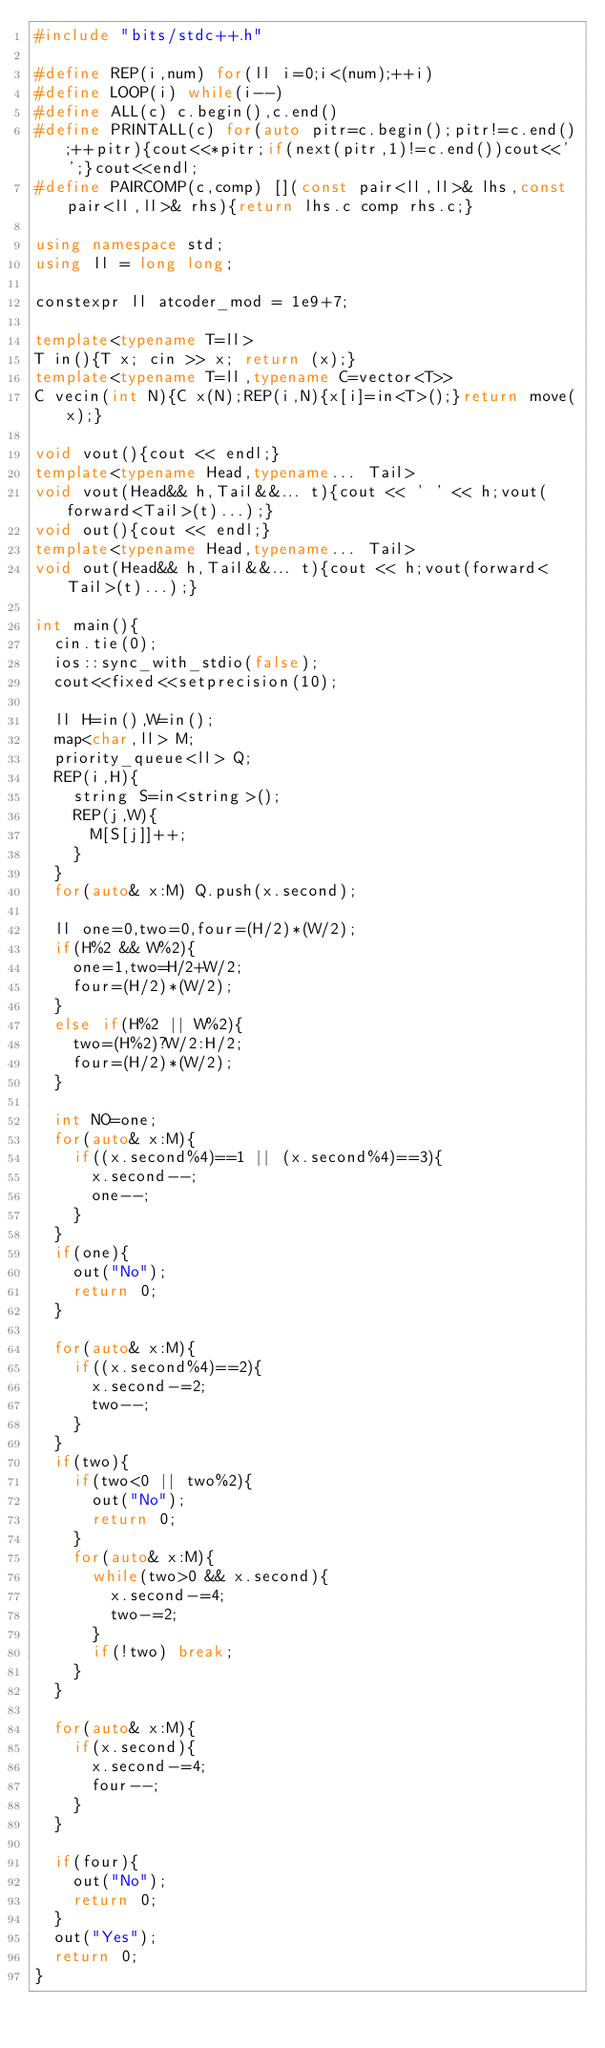Convert code to text. <code><loc_0><loc_0><loc_500><loc_500><_C++_>#include "bits/stdc++.h"

#define REP(i,num) for(ll i=0;i<(num);++i)
#define LOOP(i) while(i--)
#define ALL(c) c.begin(),c.end()
#define PRINTALL(c) for(auto pitr=c.begin();pitr!=c.end();++pitr){cout<<*pitr;if(next(pitr,1)!=c.end())cout<<' ';}cout<<endl;
#define PAIRCOMP(c,comp) [](const pair<ll,ll>& lhs,const pair<ll,ll>& rhs){return lhs.c comp rhs.c;}

using namespace std;
using ll = long long;

constexpr ll atcoder_mod = 1e9+7;

template<typename T=ll>
T in(){T x; cin >> x; return (x);}
template<typename T=ll,typename C=vector<T>>
C vecin(int N){C x(N);REP(i,N){x[i]=in<T>();}return move(x);}

void vout(){cout << endl;}
template<typename Head,typename... Tail>
void vout(Head&& h,Tail&&... t){cout << ' ' << h;vout(forward<Tail>(t)...);}
void out(){cout << endl;}
template<typename Head,typename... Tail>
void out(Head&& h,Tail&&... t){cout << h;vout(forward<Tail>(t)...);}

int main(){
	cin.tie(0);
	ios::sync_with_stdio(false);
	cout<<fixed<<setprecision(10);

	ll H=in(),W=in();
	map<char,ll> M;
	priority_queue<ll> Q;
	REP(i,H){
		string S=in<string>();
		REP(j,W){
			M[S[j]]++;
		}
	}
	for(auto& x:M) Q.push(x.second);

	ll one=0,two=0,four=(H/2)*(W/2);
	if(H%2 && W%2){
		one=1,two=H/2+W/2;
		four=(H/2)*(W/2);
	}
	else if(H%2 || W%2){
		two=(H%2)?W/2:H/2;
		four=(H/2)*(W/2);
	}
	
	int NO=one;
	for(auto& x:M){
		if((x.second%4)==1 || (x.second%4)==3){
			x.second--;
			one--;
		}
	}
	if(one){
		out("No");
		return 0;
	}

	for(auto& x:M){
		if((x.second%4)==2){
			x.second-=2;
			two--;
		}
	}
	if(two){
		if(two<0 || two%2){
			out("No");
			return 0;
		}
		for(auto& x:M){
			while(two>0 && x.second){
				x.second-=4;
				two-=2;
			}
			if(!two) break;
		}
	}

	for(auto& x:M){
		if(x.second){
			x.second-=4;
			four--;
		}
	}

	if(four){
		out("No");
		return 0;
	}
	out("Yes");
	return 0;
}
</code> 